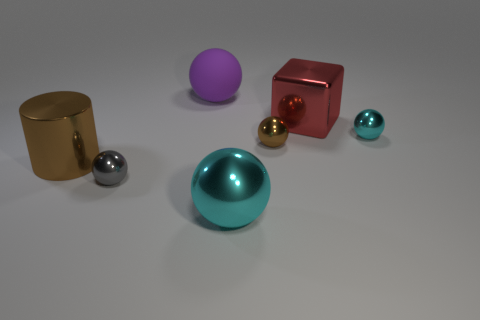Subtract all tiny balls. How many balls are left? 2 Subtract all cyan blocks. How many cyan balls are left? 2 Subtract all cyan spheres. How many spheres are left? 3 Add 3 big brown things. How many objects exist? 10 Subtract all yellow spheres. Subtract all blue cylinders. How many spheres are left? 5 Subtract all cubes. How many objects are left? 6 Subtract all matte cylinders. Subtract all gray spheres. How many objects are left? 6 Add 2 cubes. How many cubes are left? 3 Add 1 red rubber cylinders. How many red rubber cylinders exist? 1 Subtract 0 yellow cubes. How many objects are left? 7 